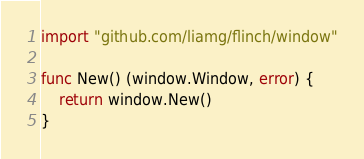<code> <loc_0><loc_0><loc_500><loc_500><_Go_>import "github.com/liamg/flinch/window"

func New() (window.Window, error) {
	return window.New()
}
</code> 